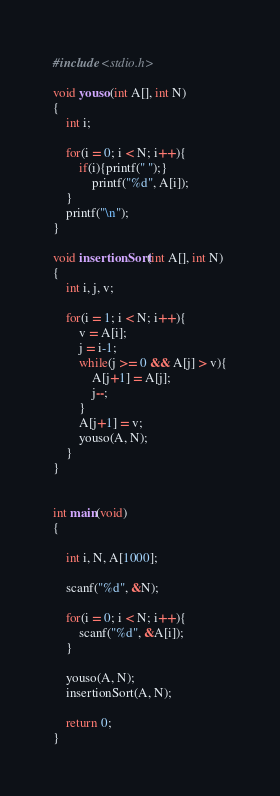Convert code to text. <code><loc_0><loc_0><loc_500><loc_500><_C_>#include <stdio.h>

void youso(int A[], int N)
{
	int i;

	for(i = 0; i < N; i++){
		if(i){printf(" ");}
			printf("%d", A[i]);
	}
	printf("\n");
}

void insertionSort(int A[], int N)
{
	int i, j, v;

	for(i = 1; i < N; i++){
		v = A[i];
		j = i-1;
		while(j >= 0 && A[j] > v){
			A[j+1] = A[j];
			j--;
		}
		A[j+1] = v;
		youso(A, N);
	}
}


int main(void)
{

	int i, N, A[1000];

	scanf("%d", &N);

	for(i = 0; i < N; i++){
		scanf("%d", &A[i]);
	}

	youso(A, N);
	insertionSort(A, N);

	return 0;
}

</code> 